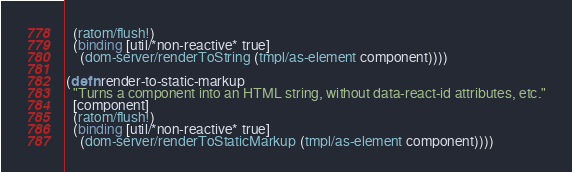<code> <loc_0><loc_0><loc_500><loc_500><_Clojure_>  (ratom/flush!)
  (binding [util/*non-reactive* true]
    (dom-server/renderToString (tmpl/as-element component))))

(defn render-to-static-markup
  "Turns a component into an HTML string, without data-react-id attributes, etc."
  [component]
  (ratom/flush!)
  (binding [util/*non-reactive* true]
    (dom-server/renderToStaticMarkup (tmpl/as-element component))))
</code> 